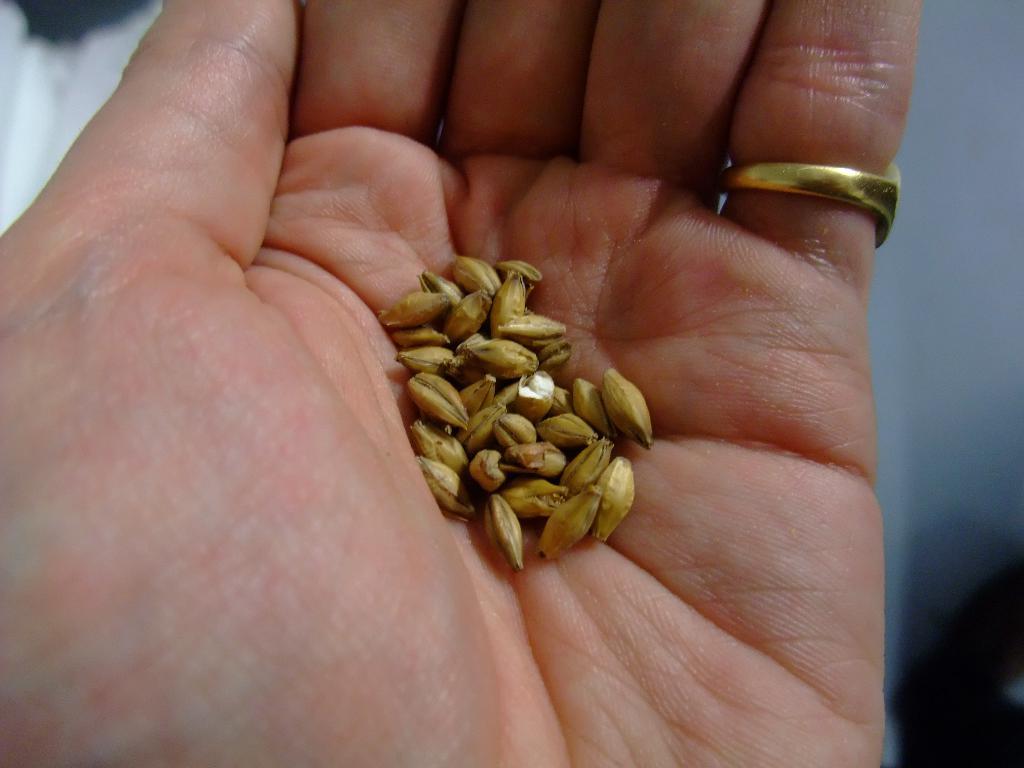How would you summarize this image in a sentence or two? In this picture I can see a human hand and we see a ring to the finger and few grains in the hand. 